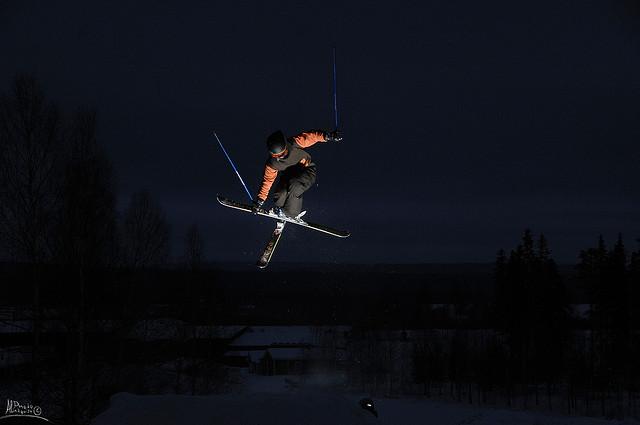Is it day time?
Concise answer only. No. Is the person doing a ski trick?
Be succinct. Yes. Is this day time?
Short answer required. No. Who is in the air?
Quick response, please. Skier. 